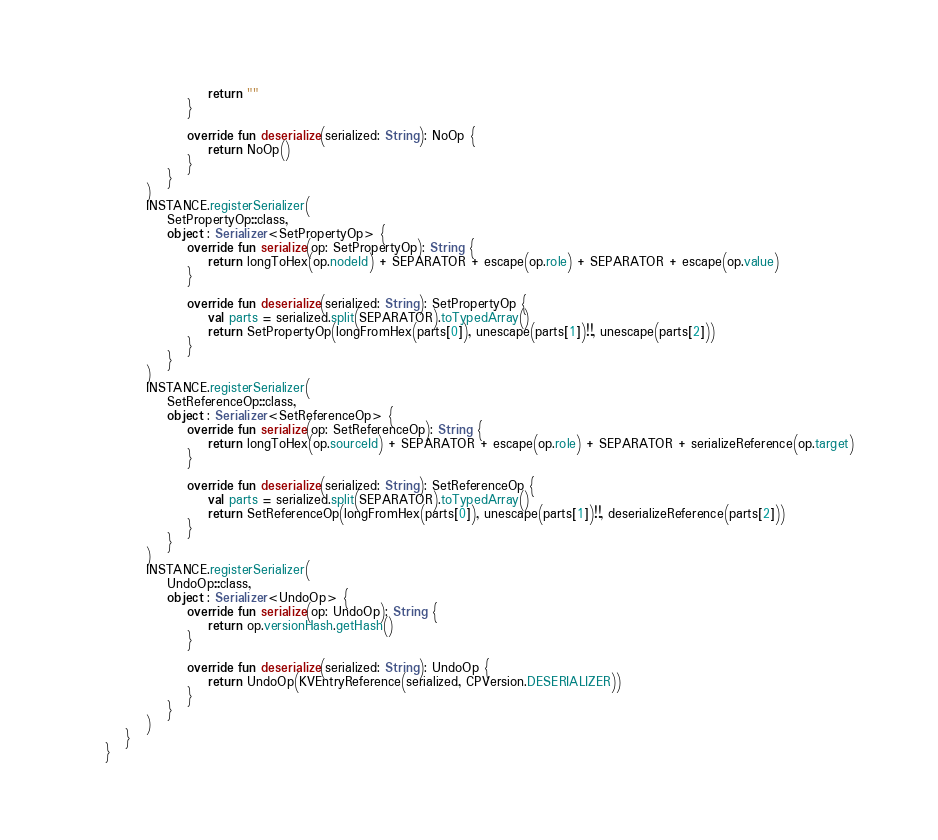<code> <loc_0><loc_0><loc_500><loc_500><_Kotlin_>                        return ""
                    }

                    override fun deserialize(serialized: String): NoOp {
                        return NoOp()
                    }
                }
            )
            INSTANCE.registerSerializer(
                SetPropertyOp::class,
                object : Serializer<SetPropertyOp> {
                    override fun serialize(op: SetPropertyOp): String {
                        return longToHex(op.nodeId) + SEPARATOR + escape(op.role) + SEPARATOR + escape(op.value)
                    }

                    override fun deserialize(serialized: String): SetPropertyOp {
                        val parts = serialized.split(SEPARATOR).toTypedArray()
                        return SetPropertyOp(longFromHex(parts[0]), unescape(parts[1])!!, unescape(parts[2]))
                    }
                }
            )
            INSTANCE.registerSerializer(
                SetReferenceOp::class,
                object : Serializer<SetReferenceOp> {
                    override fun serialize(op: SetReferenceOp): String {
                        return longToHex(op.sourceId) + SEPARATOR + escape(op.role) + SEPARATOR + serializeReference(op.target)
                    }

                    override fun deserialize(serialized: String): SetReferenceOp {
                        val parts = serialized.split(SEPARATOR).toTypedArray()
                        return SetReferenceOp(longFromHex(parts[0]), unescape(parts[1])!!, deserializeReference(parts[2]))
                    }
                }
            )
            INSTANCE.registerSerializer(
                UndoOp::class,
                object : Serializer<UndoOp> {
                    override fun serialize(op: UndoOp): String {
                        return op.versionHash.getHash()
                    }

                    override fun deserialize(serialized: String): UndoOp {
                        return UndoOp(KVEntryReference(serialized, CPVersion.DESERIALIZER))
                    }
                }
            )
        }
    }
</code> 